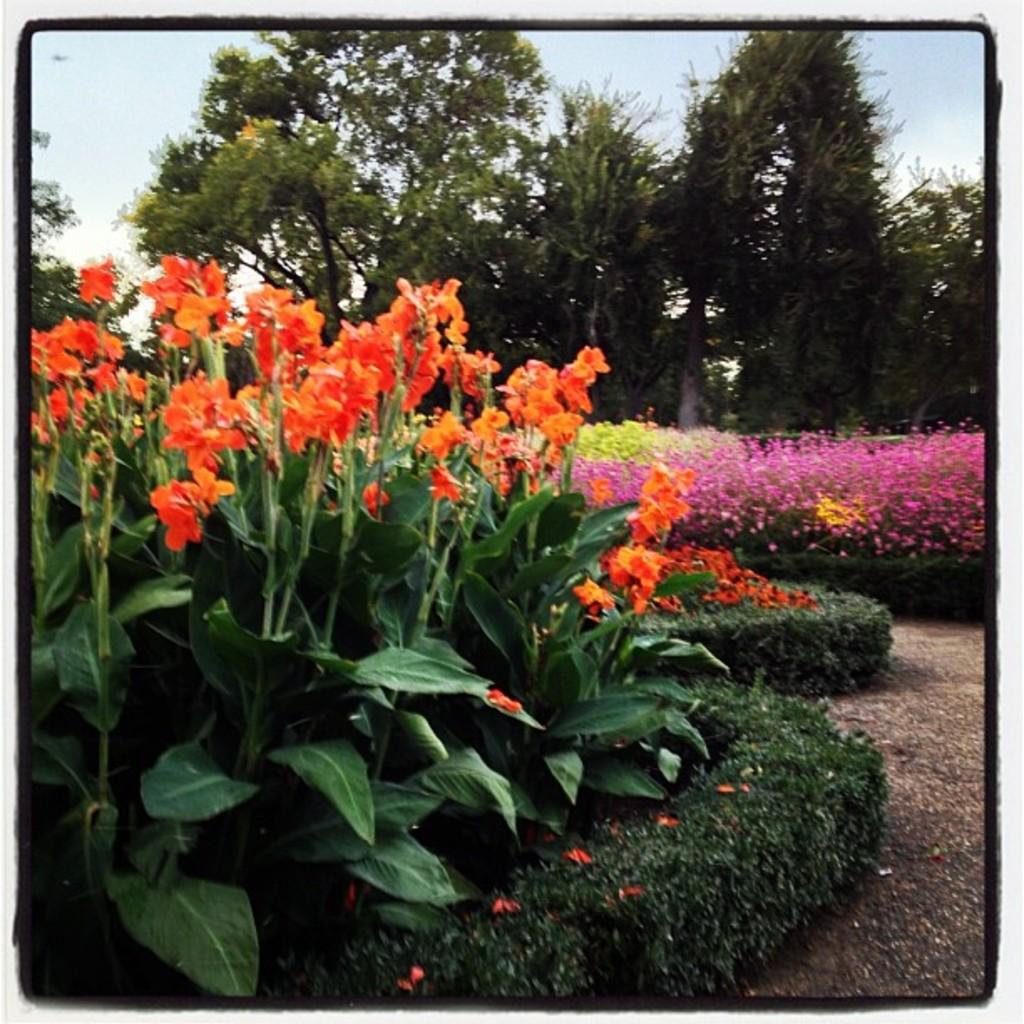What type of plants can be seen in the image? There are flower plants in the image. What can be seen in the background of the image? There are trees and the sky visible in the background of the image. How many cherries are hanging from the sock in the image? There is no sock or cherries present in the image. 